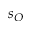Convert formula to latex. <formula><loc_0><loc_0><loc_500><loc_500>s _ { O }</formula> 